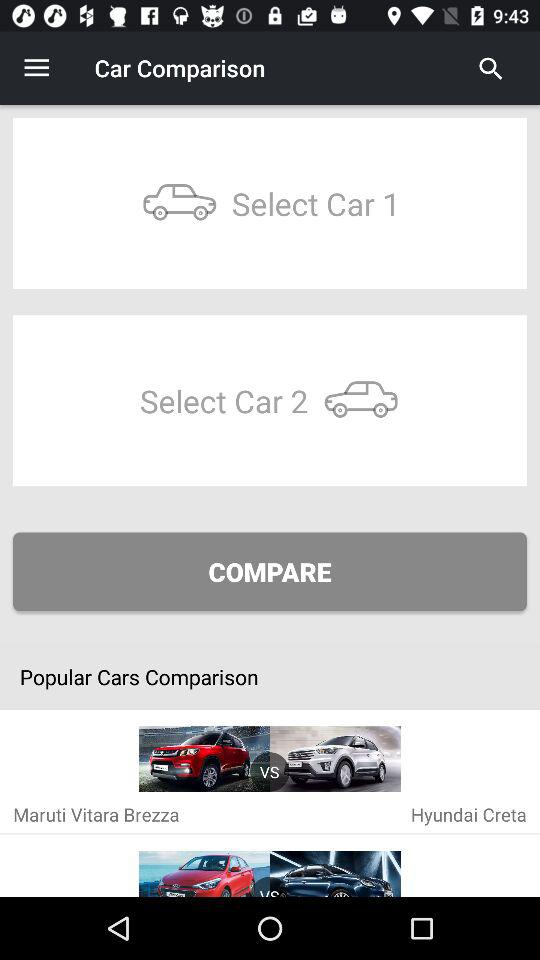Which cars are compared in the "Popular Cars Comparison" section? The cars that are compared in the "Popular Cars Comparison" section are "Maruti Vitara Brezza" and "Hyundai Creta". 